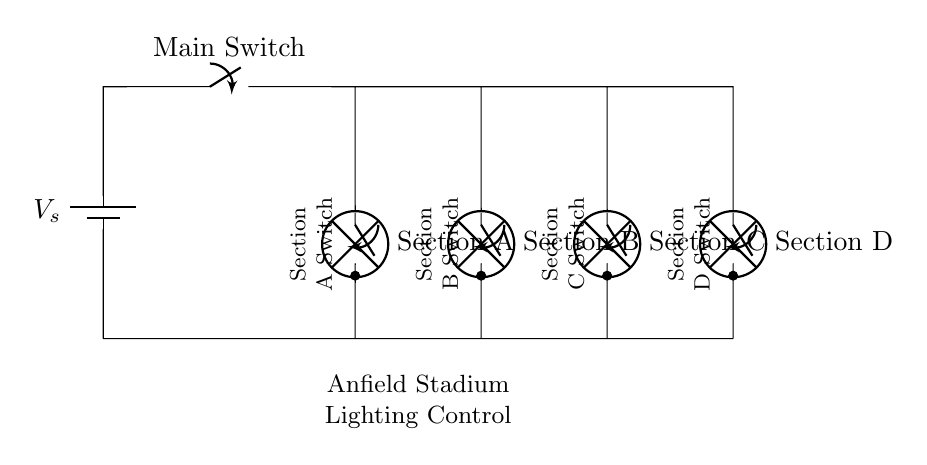What type of circuit is this? This circuit is a parallel circuit as indicated by the way multiple components (lamps in this case) are connected across the same voltage source. Each lamp's switch can control it independently without affecting others.
Answer: Parallel circuit How many sections of lights are there? The circuit diagram shows four distinct sections labeled A, B, C, and D, each corresponding to a lamp that can be controlled separately.
Answer: Four sections What is the function of the main switch? The main switch controls the flow of electricity to the entire circuit. If it is open, no section will receive power; if closed, all sections can be controlled individually.
Answer: Power control How many switches are used for individual section control? There is one switch for each of the four sections of lighting, allowing independent control, so the total is four switches.
Answer: Four switches Which sections can be turned on or off independently? Sections A, B, C, and D can each be turned on or off individually via their respective switches, allowing for targeted lighting control across the stadium.
Answer: A, B, C, D What happens if one lamp fails in this circuit? In a parallel circuit, if one lamp (or section) fails, the other sections will continue to work because the current can still flow through the other paths.
Answer: Other lamps remain on 